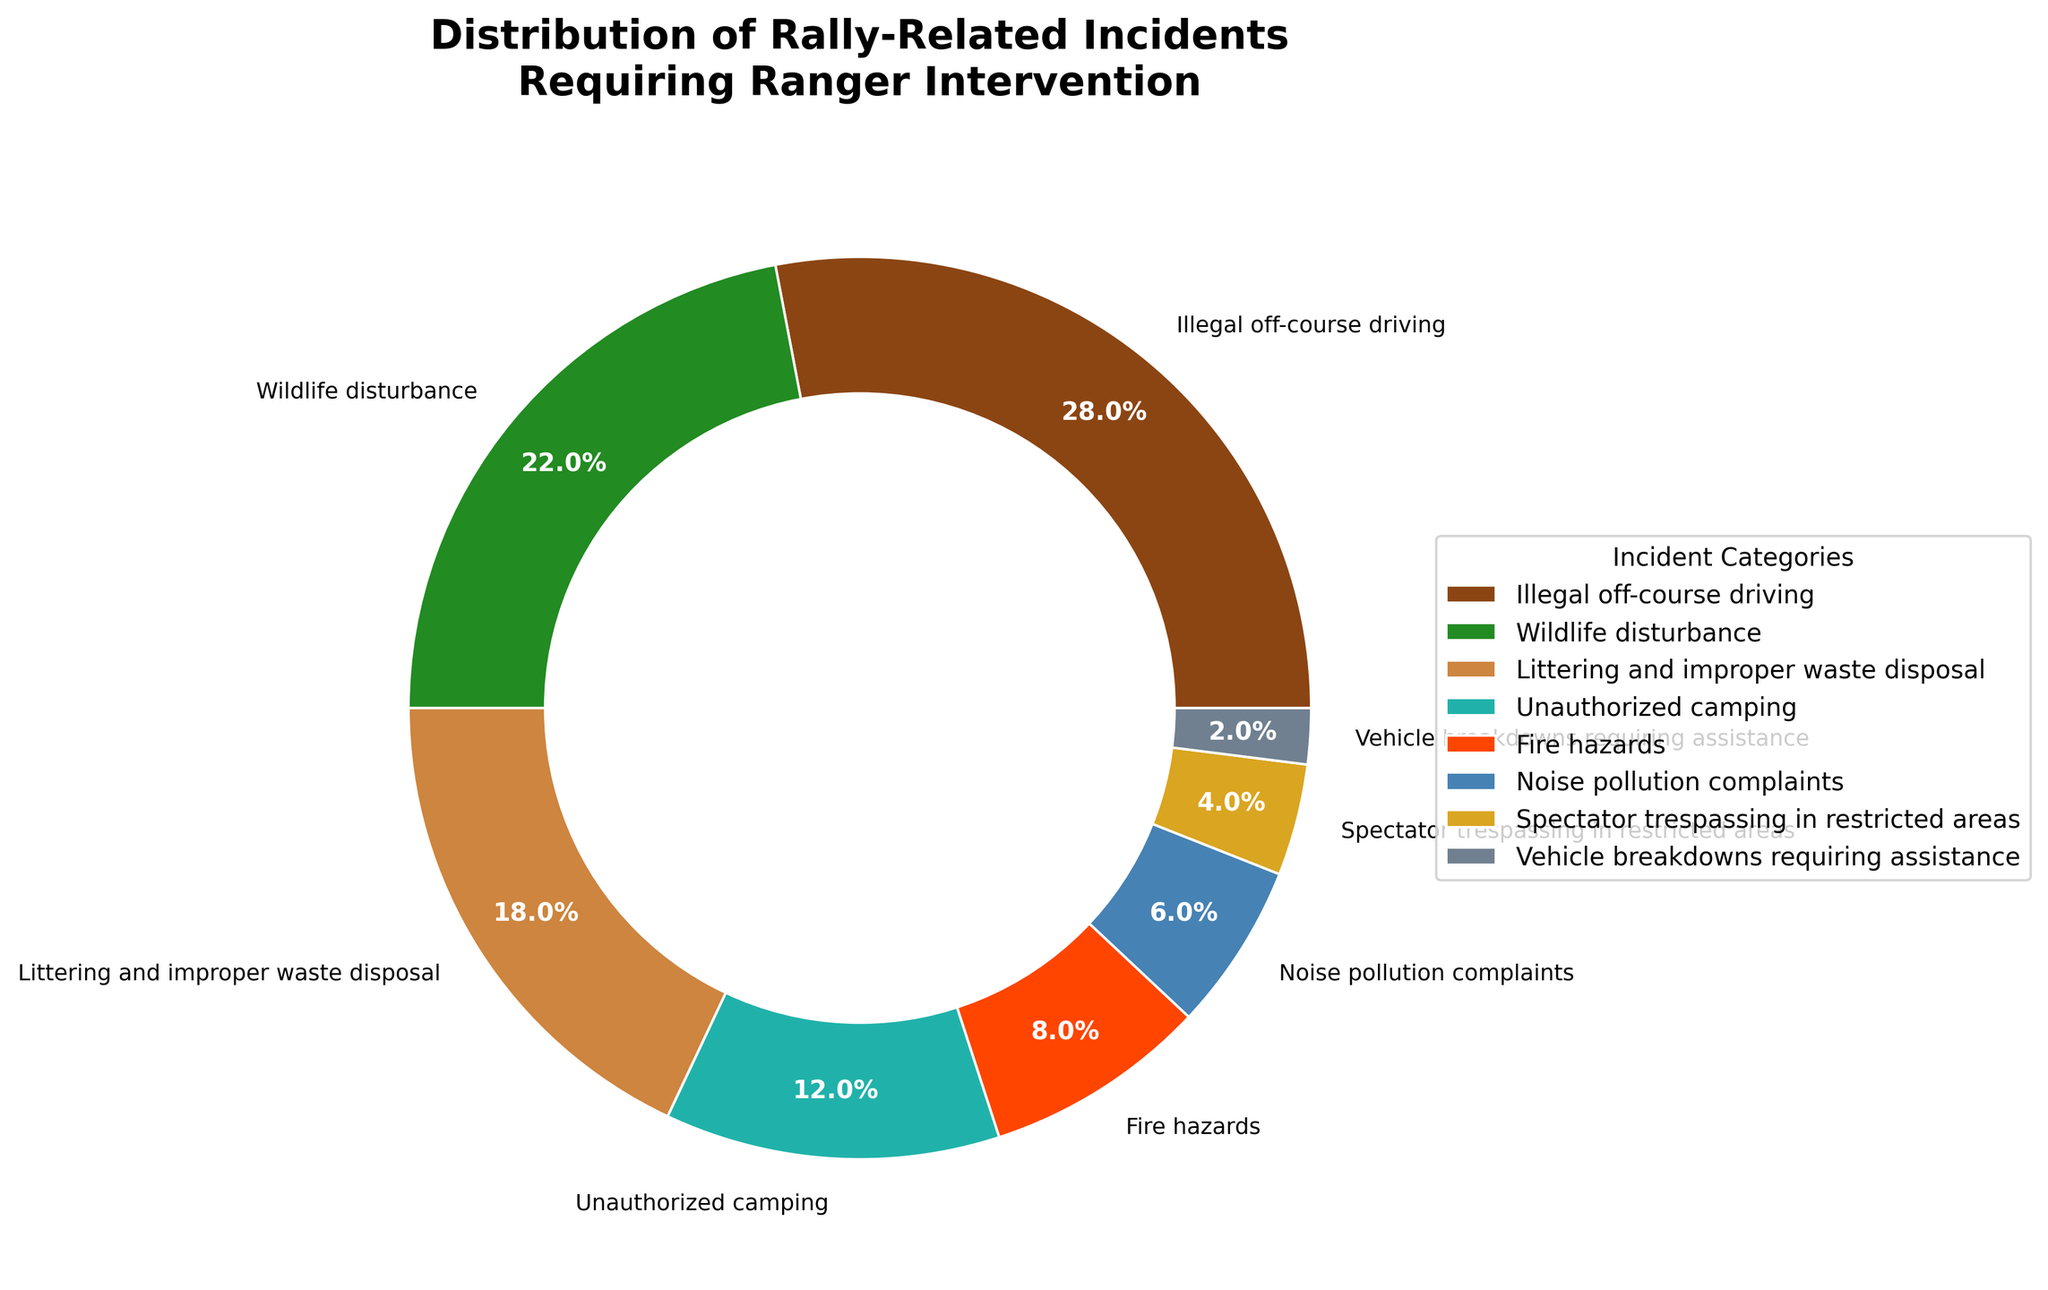Which category of rally-related incidents has the highest percentage? This question directly refers to the slice with the largest value in the pie chart. We see that "Illegal off-course driving" has the largest portion, which is clearly marked with 28%.
Answer: Illegal off-course driving Which category has a 6% incidence rate? Look at the slices of the pie chart and read the labels. The slice with a 6% label corresponds to the "Noise pollution complaints" category.
Answer: Noise pollution complaints How much greater is the percentage of Illegal off-course driving compared to Vehicle breakdowns requiring assistance? Illegal off-course driving is 28%, and Vehicle breakdowns requiring assistance is 2%. The difference is 28% - 2% = 26%.
Answer: 26% What is the combined percentage of Wildlife disturbance and Unauthorized camping? Wildlife disturbance is 22%, and Unauthorized camping is 12%. Adding them together gives 22% + 12% = 34%.
Answer: 34% Which category has the smallest percentage of incidents? Look at the smallest slice in the pie chart. The label reads "Vehicle breakdowns requiring assistance" with 2%.
Answer: Vehicle breakdowns requiring assistance What color is used for the category with the highest percentage? Refer to the slice of the pie chart labeled with 28% for "Illegal off-course driving" and check its color. The color used is brown.
Answer: Brown If you combine the percentage of Fire hazards and Unauthorized camping, does it surpass Wildlife disturbance? Fire hazards are at 8%, and Unauthorized camping is at 12%. Combined, they are 8% + 12% = 20%. Wildlife disturbance is 22%, which is greater than 20%.
Answer: No Is the percentage of Littering and improper waste disposal greater than Noise pollution complaints and Vehicle breakdowns requiring assistance combined? Littering and improper waste disposal is 18%. Noise pollution complaints are 6%, and Vehicle breakdowns requiring assistance are 2%. Together they sum to 6% + 2% = 8%, which is less than 18%.
Answer: Yes What is the total percentage of incidents represented by the three largest categories? The three largest categories are Illegal off-course driving (28%), Wildlife disturbance (22%), and Littering and improper waste disposal (18%). Sum them up: 28% + 22% + 18% = 68%.
Answer: 68% 